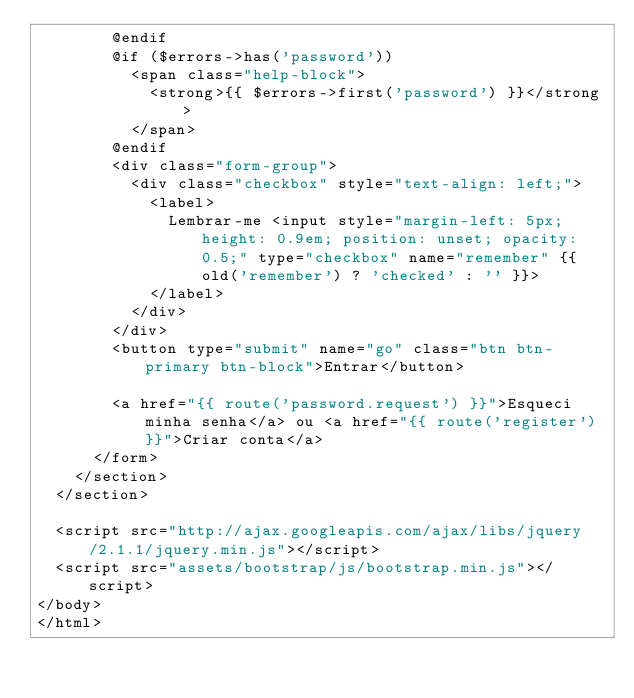<code> <loc_0><loc_0><loc_500><loc_500><_PHP_>				@endif
				@if ($errors->has('password'))
					<span class="help-block">
						<strong>{{ $errors->first('password') }}</strong>
					</span>
				@endif
				<div class="form-group">
					<div class="checkbox" style="text-align: left;">
						<label>
							Lembrar-me <input style="margin-left: 5px; height: 0.9em; position: unset; opacity: 0.5;" type="checkbox" name="remember" {{ old('remember') ? 'checked' : '' }}>
						</label>
					</div>
				</div>
				<button type="submit" name="go" class="btn btn-primary btn-block">Entrar</button>
				
				<a href="{{ route('password.request') }}">Esqueci minha senha</a> ou <a href="{{ route('register') }}">Criar conta</a>
			</form>
		</section>
	</section>
	
	<script src="http://ajax.googleapis.com/ajax/libs/jquery/2.1.1/jquery.min.js"></script>
	<script src="assets/bootstrap/js/bootstrap.min.js"></script>
</body>
</html></code> 